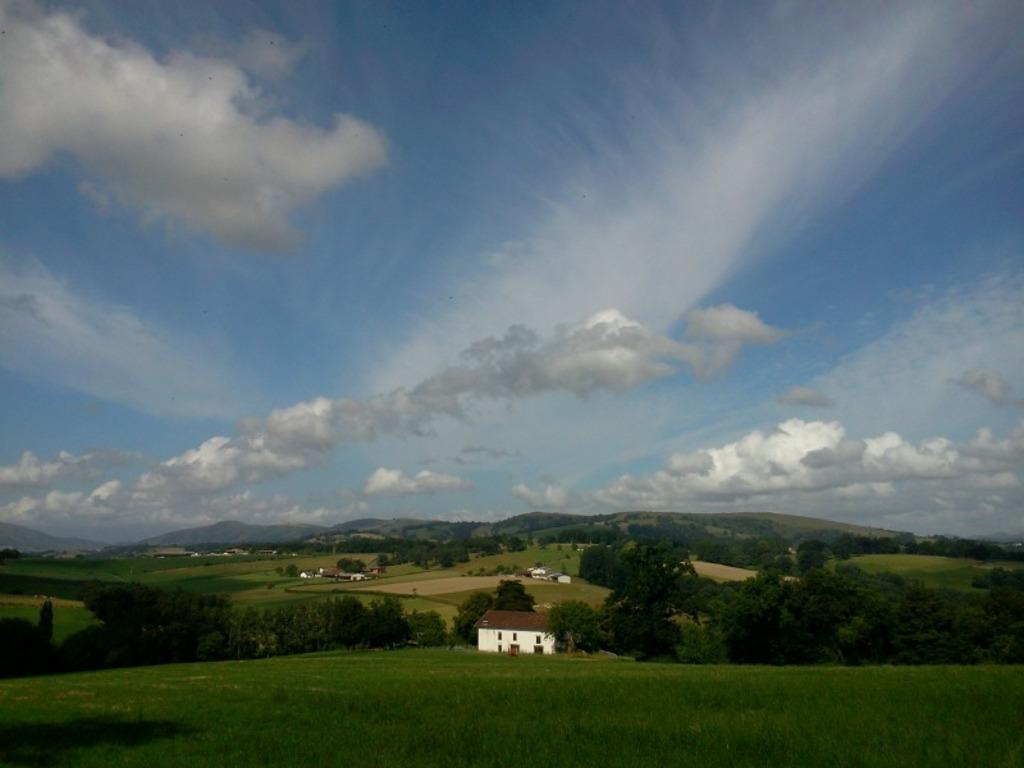What type of structures can be seen in the image? There are houses in the image. What other natural elements are present in the image? There are trees in the image. What is located in front of the houses? There is a garden in front of the houses. What can be seen in the distance behind the houses? Mountains are visible in the background. How would you describe the color of the sky in the image? The sky is blue and white in color. How many brothers are playing with the invention in the garden? There is no mention of brothers or an invention in the image. The image only shows houses, trees, a garden, mountains, and a blue and white sky. 